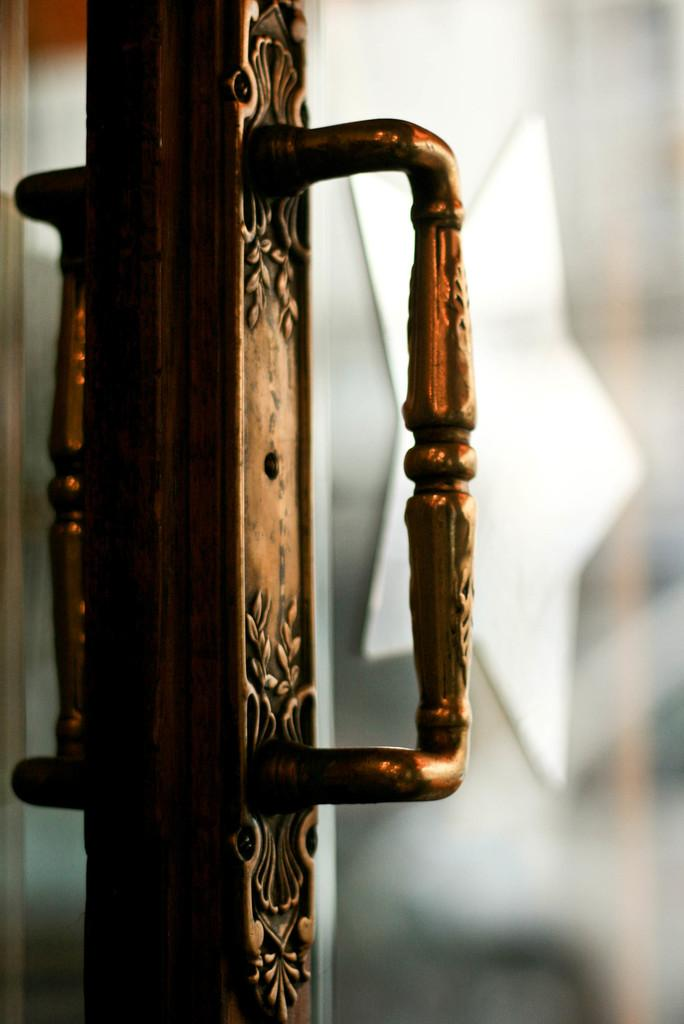What object is located on the left side of the image? There is a door handle on the left side of the image. What is the primary function of the object on the left side of the image? The door handle is used for opening and closing a door. How many fairies are flying around the door handle in the image? There are no fairies present in the image. What type of kite is attached to the door handle in the image? There is no kite attached to the door handle in the image. 